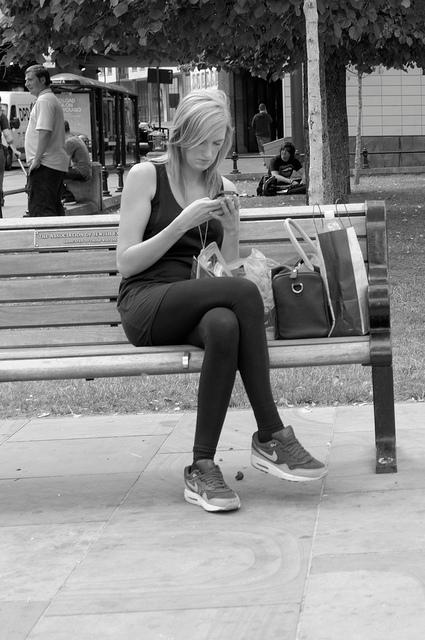What are the shoes that the girl is wearing a good use for?

Choices:
A) ballet
B) snowboarding
C) running
D) swimming running 